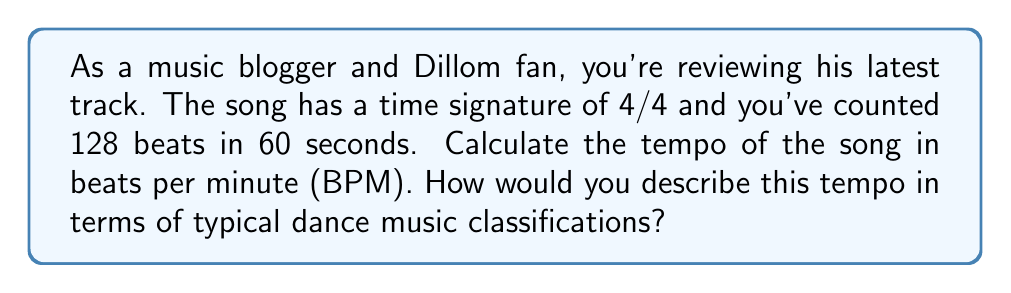Give your solution to this math problem. To solve this problem, we need to follow these steps:

1. Understand the given information:
   - Time signature: 4/4
   - Counted beats: 128
   - Time duration: 60 seconds

2. Calculate the tempo in BPM:
   The tempo in BPM is simply the number of beats per minute. Since we have the number of beats in 60 seconds (which is one minute), we can directly use this value:

   $$\text{Tempo (BPM)} = \frac{\text{Number of beats}}{\text{Time in minutes}} = \frac{128}{1} = 128 \text{ BPM}$$

3. Classify the tempo:
   In electronic and dance music, tempos are often classified as follows:
   - Slow: Below 90 BPM
   - Moderate: 90-120 BPM
   - Fast: 120-140 BPM
   - Very fast: Above 140 BPM

   A tempo of 128 BPM falls into the "Fast" category, which is common for genres like house, techno, and some forms of EDM (Electronic Dance Music).

This tempo would typically create an energetic, danceable rhythm, which could be relevant when describing Dillom's music in your blog review.
Answer: The tempo of the song is 128 BPM, which is classified as "Fast" in typical dance music classifications. 